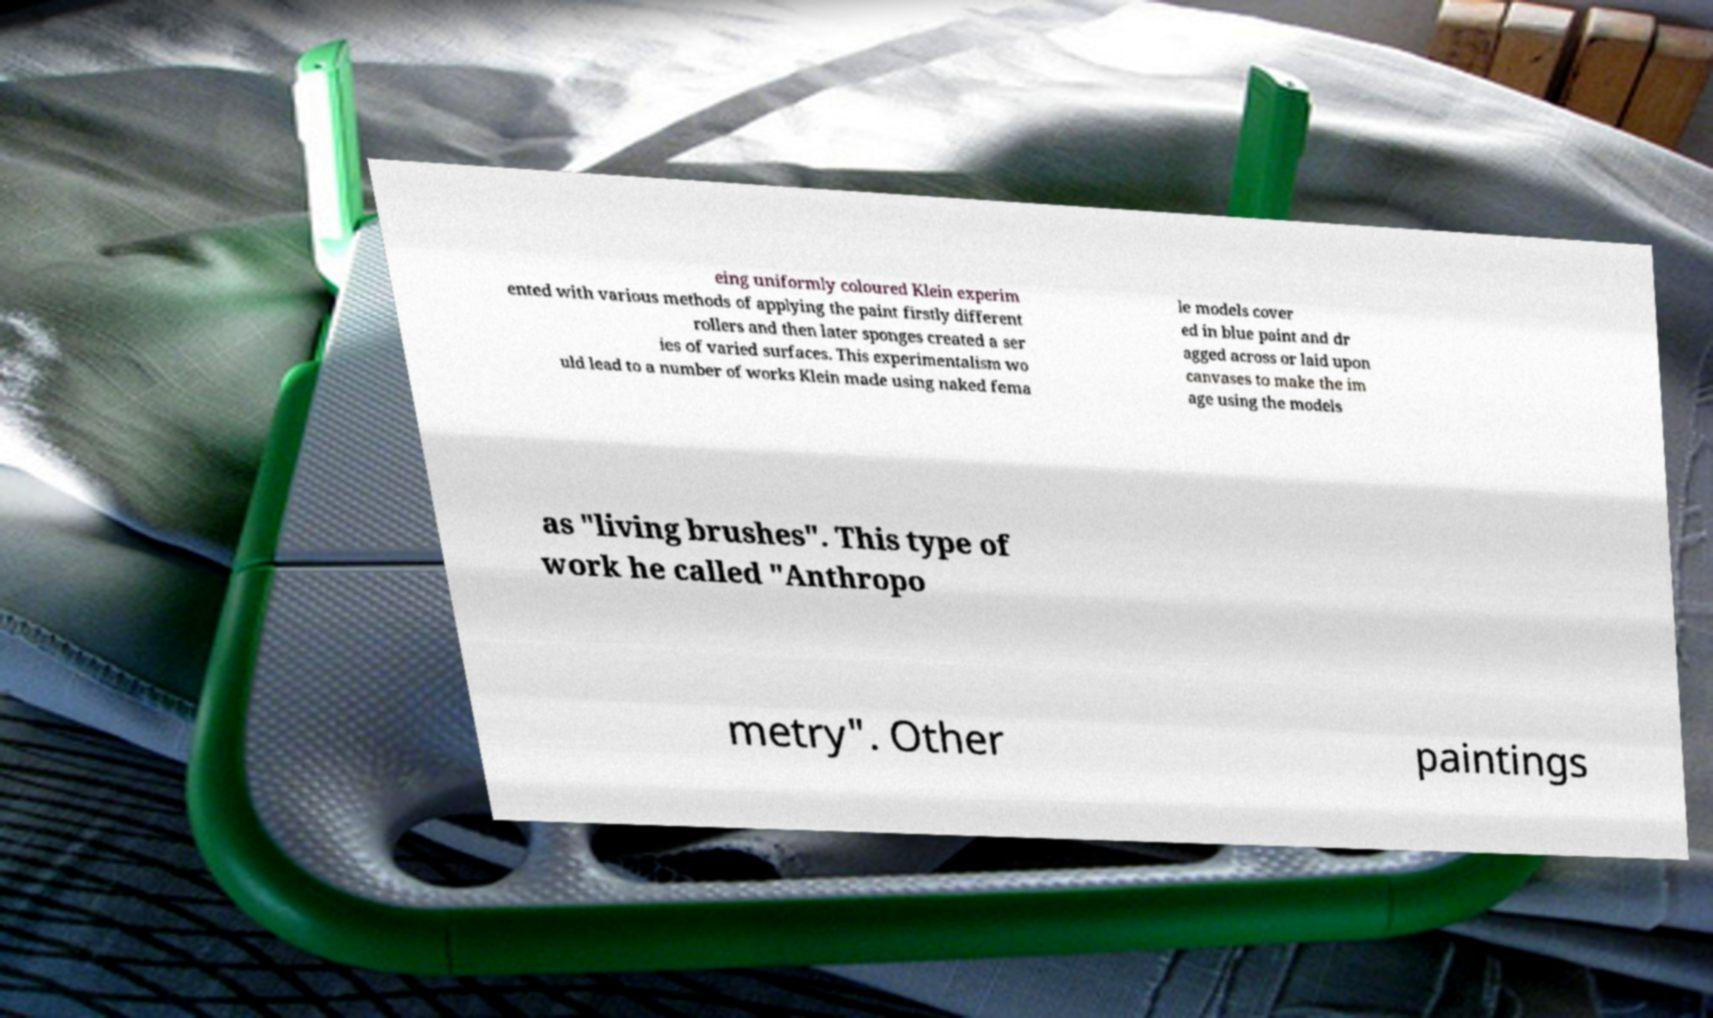Please read and relay the text visible in this image. What does it say? eing uniformly coloured Klein experim ented with various methods of applying the paint firstly different rollers and then later sponges created a ser ies of varied surfaces. This experimentalism wo uld lead to a number of works Klein made using naked fema le models cover ed in blue paint and dr agged across or laid upon canvases to make the im age using the models as "living brushes". This type of work he called "Anthropo metry". Other paintings 